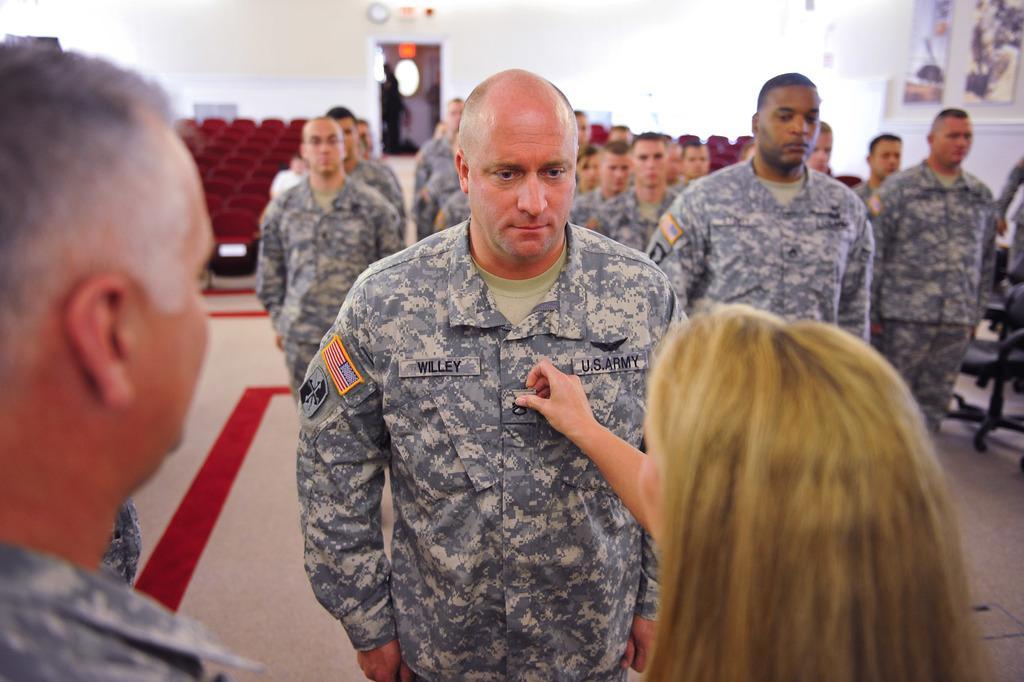Could you give a brief overview of what you see in this image? In this image there are two persons standing , a person holding another person shirt, and at the background there are group of persons standing, chairs,frames attached to wall, carpet. 